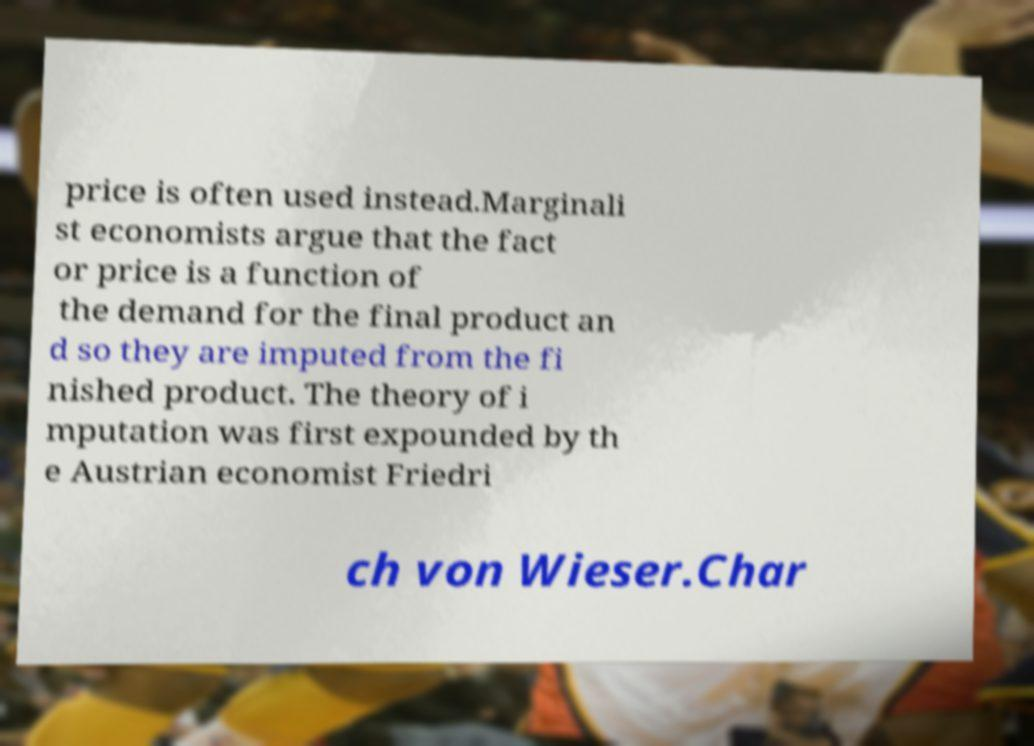Could you extract and type out the text from this image? price is often used instead.Marginali st economists argue that the fact or price is a function of the demand for the final product an d so they are imputed from the fi nished product. The theory of i mputation was first expounded by th e Austrian economist Friedri ch von Wieser.Char 